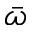Convert formula to latex. <formula><loc_0><loc_0><loc_500><loc_500>\bar { \omega }</formula> 